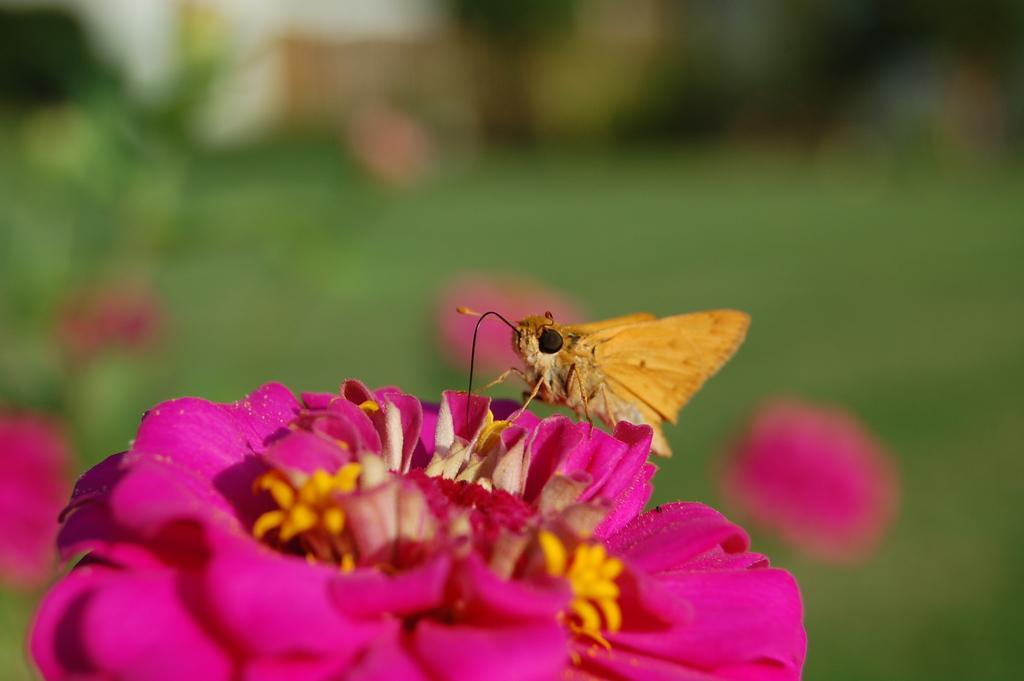How would you summarize this image in a sentence or two? In this image there is a insect sitting on the flower behind that there are so many plants and flowers. 